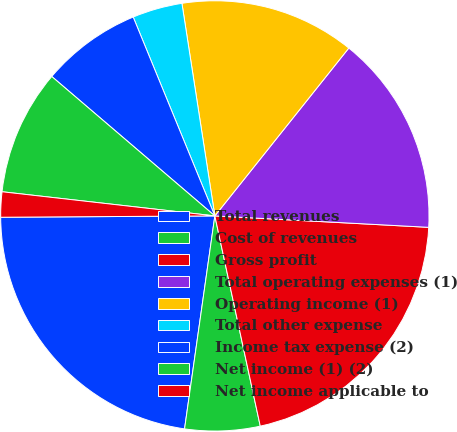Convert chart. <chart><loc_0><loc_0><loc_500><loc_500><pie_chart><fcel>Total revenues<fcel>Cost of revenues<fcel>Gross profit<fcel>Total operating expenses (1)<fcel>Operating income (1)<fcel>Total other expense<fcel>Income tax expense (2)<fcel>Net income (1) (2)<fcel>Net income applicable to<nl><fcel>22.64%<fcel>5.66%<fcel>20.75%<fcel>15.09%<fcel>13.21%<fcel>3.77%<fcel>7.55%<fcel>9.43%<fcel>1.89%<nl></chart> 